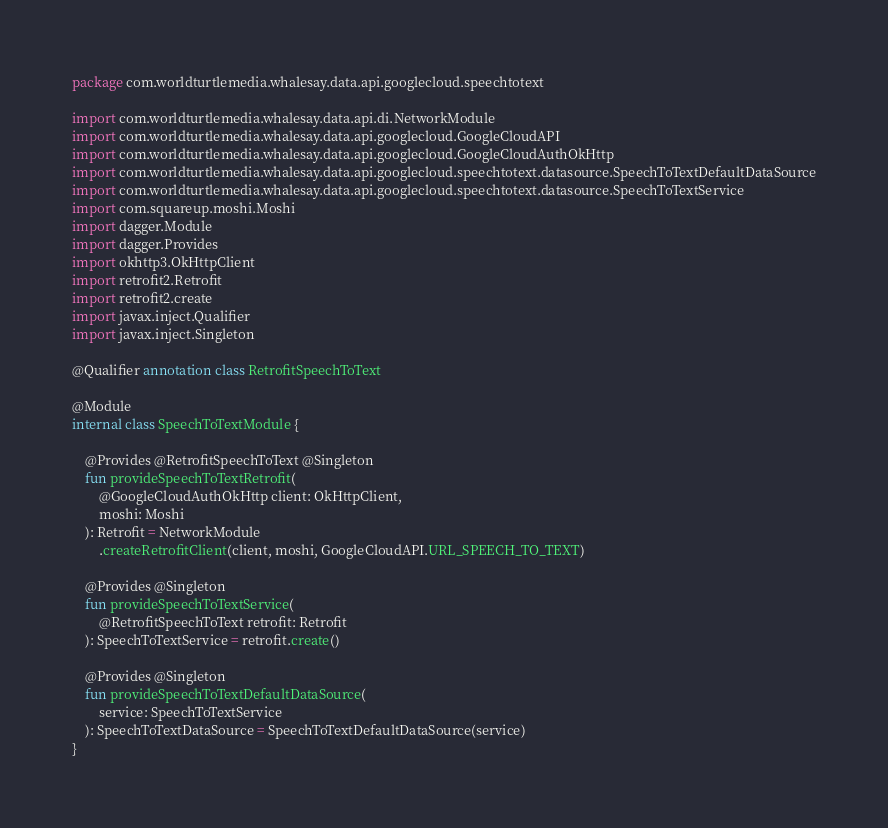<code> <loc_0><loc_0><loc_500><loc_500><_Kotlin_>package com.worldturtlemedia.whalesay.data.api.googlecloud.speechtotext

import com.worldturtlemedia.whalesay.data.api.di.NetworkModule
import com.worldturtlemedia.whalesay.data.api.googlecloud.GoogleCloudAPI
import com.worldturtlemedia.whalesay.data.api.googlecloud.GoogleCloudAuthOkHttp
import com.worldturtlemedia.whalesay.data.api.googlecloud.speechtotext.datasource.SpeechToTextDefaultDataSource
import com.worldturtlemedia.whalesay.data.api.googlecloud.speechtotext.datasource.SpeechToTextService
import com.squareup.moshi.Moshi
import dagger.Module
import dagger.Provides
import okhttp3.OkHttpClient
import retrofit2.Retrofit
import retrofit2.create
import javax.inject.Qualifier
import javax.inject.Singleton

@Qualifier annotation class RetrofitSpeechToText

@Module
internal class SpeechToTextModule {

    @Provides @RetrofitSpeechToText @Singleton
    fun provideSpeechToTextRetrofit(
        @GoogleCloudAuthOkHttp client: OkHttpClient,
        moshi: Moshi
    ): Retrofit = NetworkModule
        .createRetrofitClient(client, moshi, GoogleCloudAPI.URL_SPEECH_TO_TEXT)

    @Provides @Singleton
    fun provideSpeechToTextService(
        @RetrofitSpeechToText retrofit: Retrofit
    ): SpeechToTextService = retrofit.create()

    @Provides @Singleton
    fun provideSpeechToTextDefaultDataSource(
        service: SpeechToTextService
    ): SpeechToTextDataSource = SpeechToTextDefaultDataSource(service)
}
</code> 